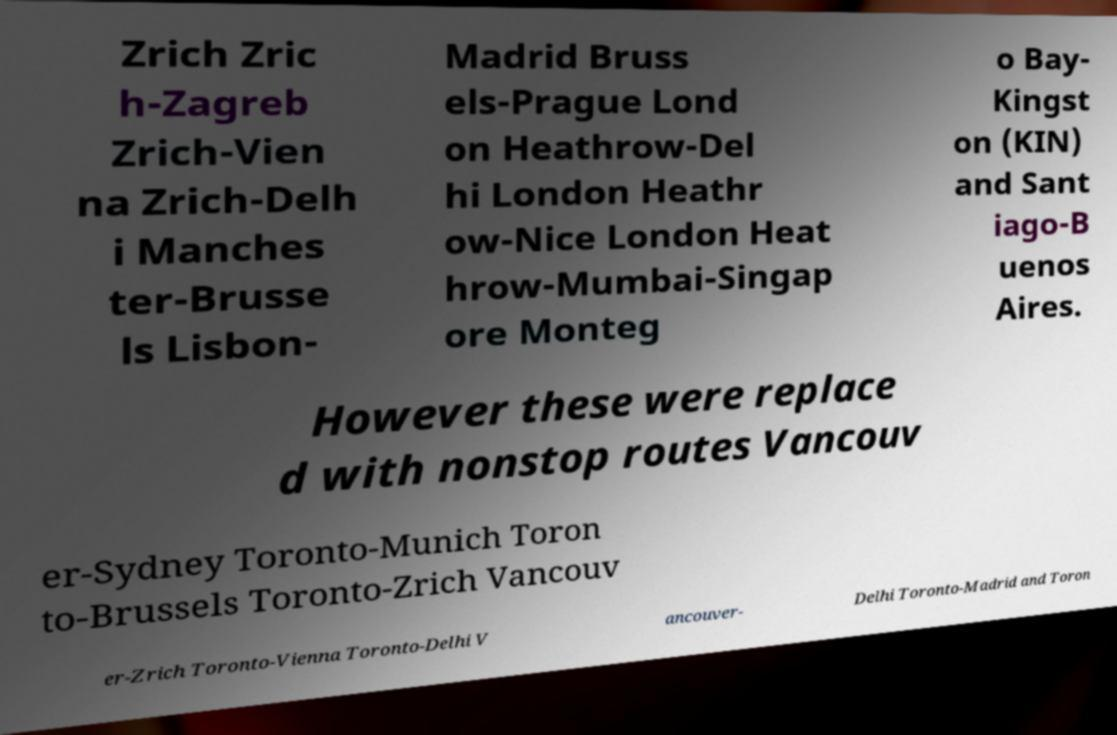Can you accurately transcribe the text from the provided image for me? Zrich Zric h-Zagreb Zrich-Vien na Zrich-Delh i Manches ter-Brusse ls Lisbon- Madrid Bruss els-Prague Lond on Heathrow-Del hi London Heathr ow-Nice London Heat hrow-Mumbai-Singap ore Monteg o Bay- Kingst on (KIN) and Sant iago-B uenos Aires. However these were replace d with nonstop routes Vancouv er-Sydney Toronto-Munich Toron to-Brussels Toronto-Zrich Vancouv er-Zrich Toronto-Vienna Toronto-Delhi V ancouver- Delhi Toronto-Madrid and Toron 